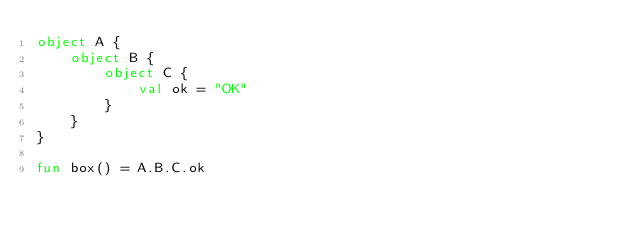Convert code to text. <code><loc_0><loc_0><loc_500><loc_500><_Kotlin_>object A {
    object B {
        object C {
            val ok = "OK"
        }
    }
}

fun box() = A.B.C.ok
</code> 